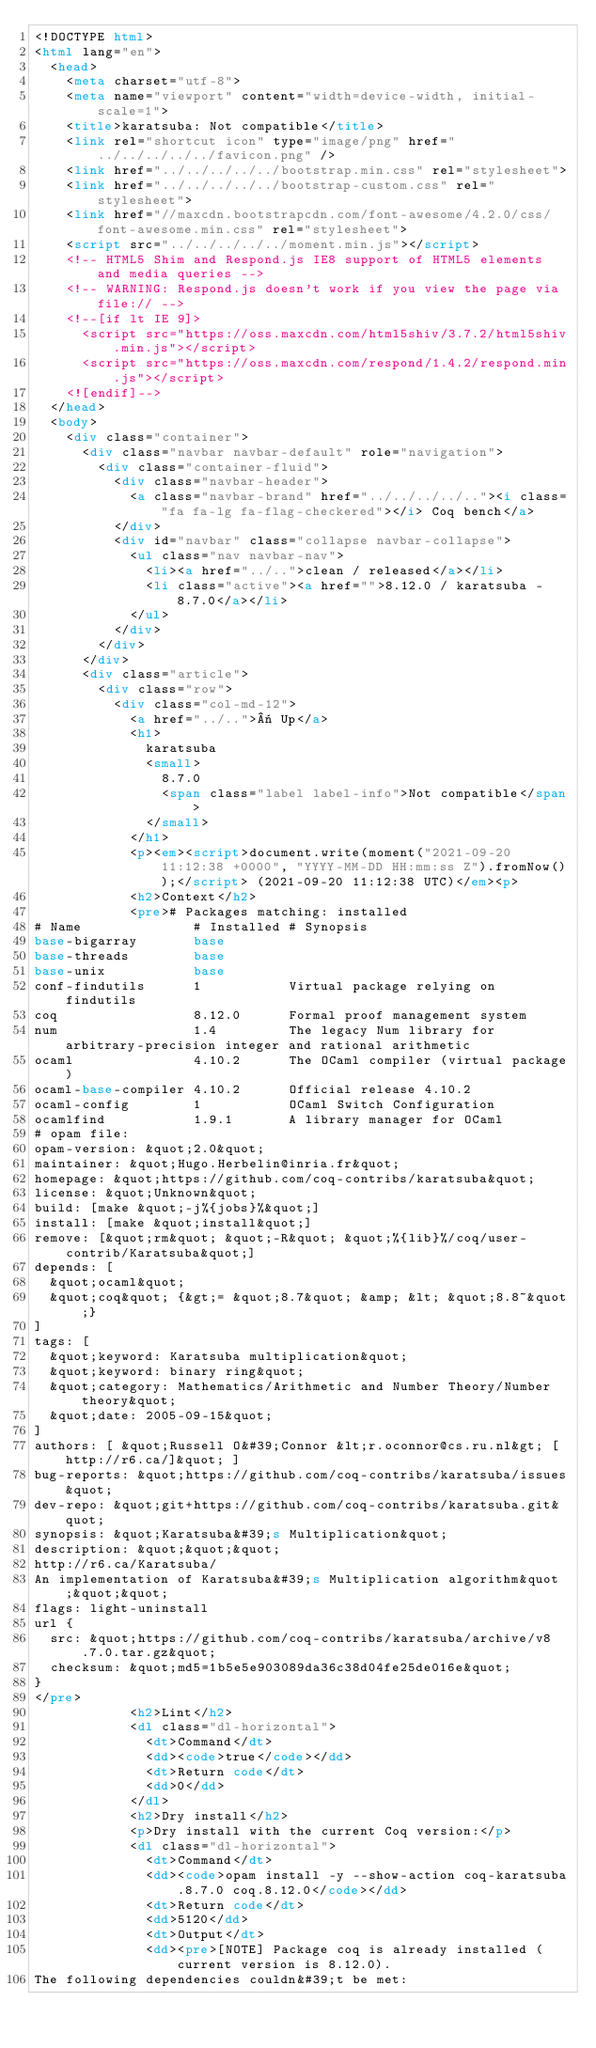Convert code to text. <code><loc_0><loc_0><loc_500><loc_500><_HTML_><!DOCTYPE html>
<html lang="en">
  <head>
    <meta charset="utf-8">
    <meta name="viewport" content="width=device-width, initial-scale=1">
    <title>karatsuba: Not compatible</title>
    <link rel="shortcut icon" type="image/png" href="../../../../../favicon.png" />
    <link href="../../../../../bootstrap.min.css" rel="stylesheet">
    <link href="../../../../../bootstrap-custom.css" rel="stylesheet">
    <link href="//maxcdn.bootstrapcdn.com/font-awesome/4.2.0/css/font-awesome.min.css" rel="stylesheet">
    <script src="../../../../../moment.min.js"></script>
    <!-- HTML5 Shim and Respond.js IE8 support of HTML5 elements and media queries -->
    <!-- WARNING: Respond.js doesn't work if you view the page via file:// -->
    <!--[if lt IE 9]>
      <script src="https://oss.maxcdn.com/html5shiv/3.7.2/html5shiv.min.js"></script>
      <script src="https://oss.maxcdn.com/respond/1.4.2/respond.min.js"></script>
    <![endif]-->
  </head>
  <body>
    <div class="container">
      <div class="navbar navbar-default" role="navigation">
        <div class="container-fluid">
          <div class="navbar-header">
            <a class="navbar-brand" href="../../../../.."><i class="fa fa-lg fa-flag-checkered"></i> Coq bench</a>
          </div>
          <div id="navbar" class="collapse navbar-collapse">
            <ul class="nav navbar-nav">
              <li><a href="../..">clean / released</a></li>
              <li class="active"><a href="">8.12.0 / karatsuba - 8.7.0</a></li>
            </ul>
          </div>
        </div>
      </div>
      <div class="article">
        <div class="row">
          <div class="col-md-12">
            <a href="../..">« Up</a>
            <h1>
              karatsuba
              <small>
                8.7.0
                <span class="label label-info">Not compatible</span>
              </small>
            </h1>
            <p><em><script>document.write(moment("2021-09-20 11:12:38 +0000", "YYYY-MM-DD HH:mm:ss Z").fromNow());</script> (2021-09-20 11:12:38 UTC)</em><p>
            <h2>Context</h2>
            <pre># Packages matching: installed
# Name              # Installed # Synopsis
base-bigarray       base
base-threads        base
base-unix           base
conf-findutils      1           Virtual package relying on findutils
coq                 8.12.0      Formal proof management system
num                 1.4         The legacy Num library for arbitrary-precision integer and rational arithmetic
ocaml               4.10.2      The OCaml compiler (virtual package)
ocaml-base-compiler 4.10.2      Official release 4.10.2
ocaml-config        1           OCaml Switch Configuration
ocamlfind           1.9.1       A library manager for OCaml
# opam file:
opam-version: &quot;2.0&quot;
maintainer: &quot;Hugo.Herbelin@inria.fr&quot;
homepage: &quot;https://github.com/coq-contribs/karatsuba&quot;
license: &quot;Unknown&quot;
build: [make &quot;-j%{jobs}%&quot;]
install: [make &quot;install&quot;]
remove: [&quot;rm&quot; &quot;-R&quot; &quot;%{lib}%/coq/user-contrib/Karatsuba&quot;]
depends: [
  &quot;ocaml&quot;
  &quot;coq&quot; {&gt;= &quot;8.7&quot; &amp; &lt; &quot;8.8~&quot;}
]
tags: [
  &quot;keyword: Karatsuba multiplication&quot;
  &quot;keyword: binary ring&quot;
  &quot;category: Mathematics/Arithmetic and Number Theory/Number theory&quot;
  &quot;date: 2005-09-15&quot;
]
authors: [ &quot;Russell O&#39;Connor &lt;r.oconnor@cs.ru.nl&gt; [http://r6.ca/]&quot; ]
bug-reports: &quot;https://github.com/coq-contribs/karatsuba/issues&quot;
dev-repo: &quot;git+https://github.com/coq-contribs/karatsuba.git&quot;
synopsis: &quot;Karatsuba&#39;s Multiplication&quot;
description: &quot;&quot;&quot;
http://r6.ca/Karatsuba/
An implementation of Karatsuba&#39;s Multiplication algorithm&quot;&quot;&quot;
flags: light-uninstall
url {
  src: &quot;https://github.com/coq-contribs/karatsuba/archive/v8.7.0.tar.gz&quot;
  checksum: &quot;md5=1b5e5e903089da36c38d04fe25de016e&quot;
}
</pre>
            <h2>Lint</h2>
            <dl class="dl-horizontal">
              <dt>Command</dt>
              <dd><code>true</code></dd>
              <dt>Return code</dt>
              <dd>0</dd>
            </dl>
            <h2>Dry install</h2>
            <p>Dry install with the current Coq version:</p>
            <dl class="dl-horizontal">
              <dt>Command</dt>
              <dd><code>opam install -y --show-action coq-karatsuba.8.7.0 coq.8.12.0</code></dd>
              <dt>Return code</dt>
              <dd>5120</dd>
              <dt>Output</dt>
              <dd><pre>[NOTE] Package coq is already installed (current version is 8.12.0).
The following dependencies couldn&#39;t be met:</code> 